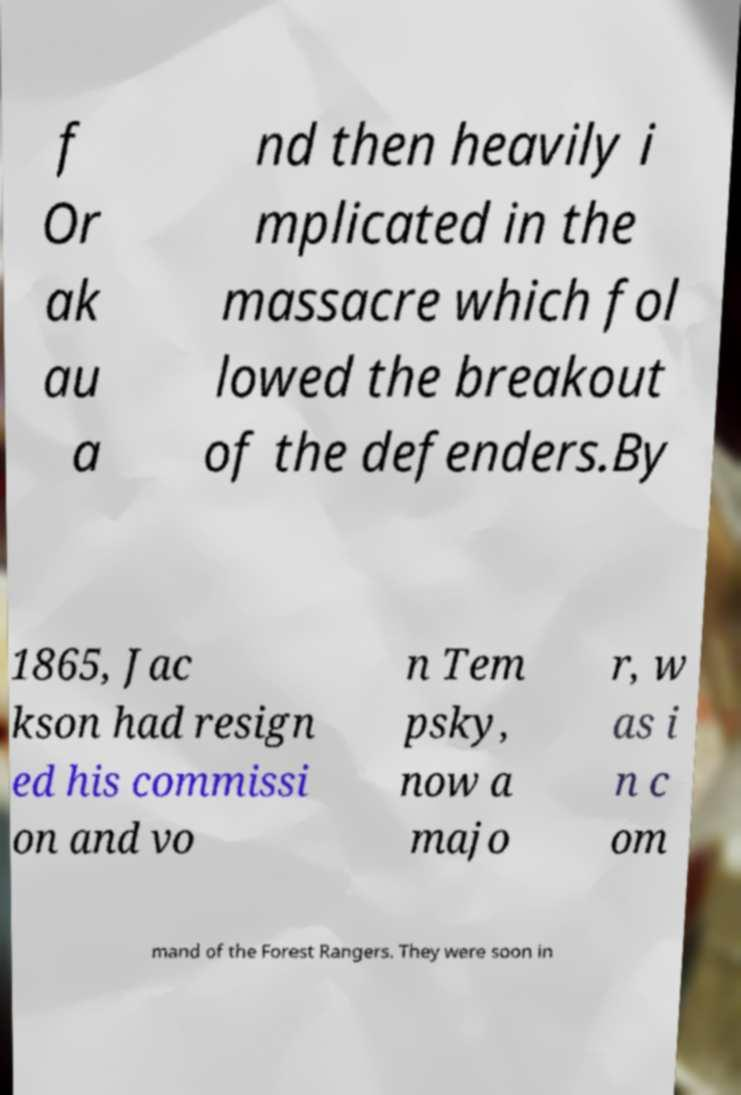Could you assist in decoding the text presented in this image and type it out clearly? f Or ak au a nd then heavily i mplicated in the massacre which fol lowed the breakout of the defenders.By 1865, Jac kson had resign ed his commissi on and vo n Tem psky, now a majo r, w as i n c om mand of the Forest Rangers. They were soon in 